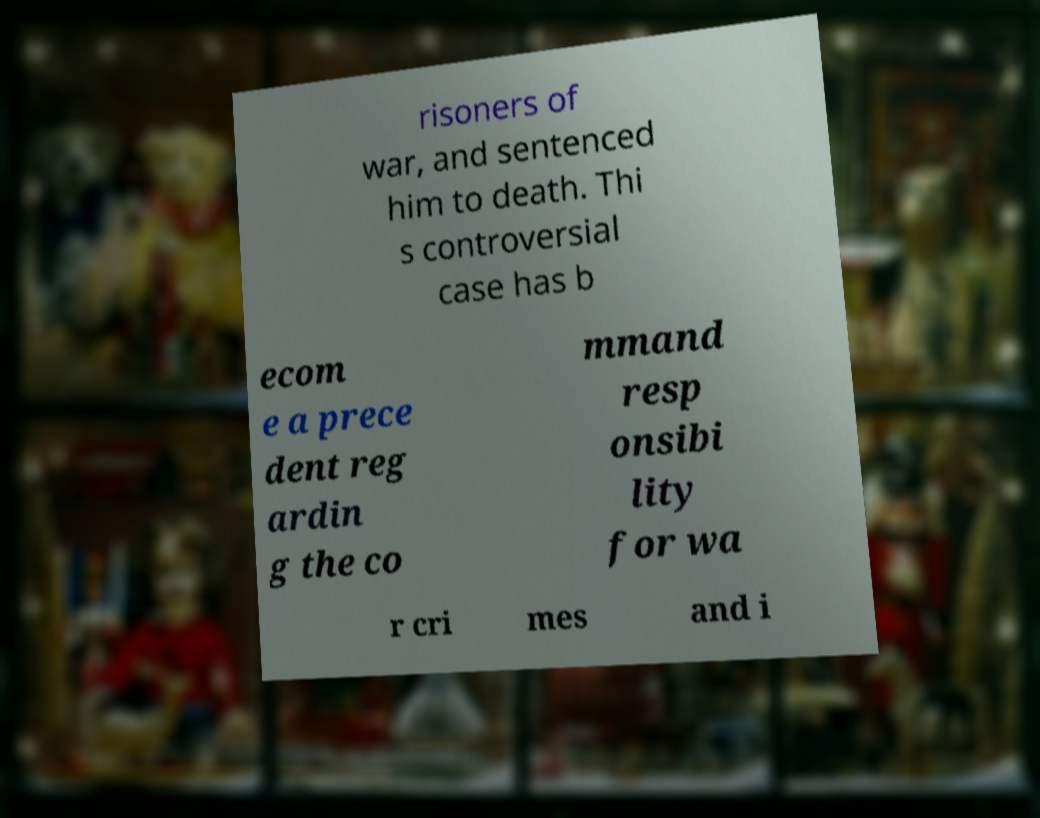Could you extract and type out the text from this image? risoners of war, and sentenced him to death. Thi s controversial case has b ecom e a prece dent reg ardin g the co mmand resp onsibi lity for wa r cri mes and i 